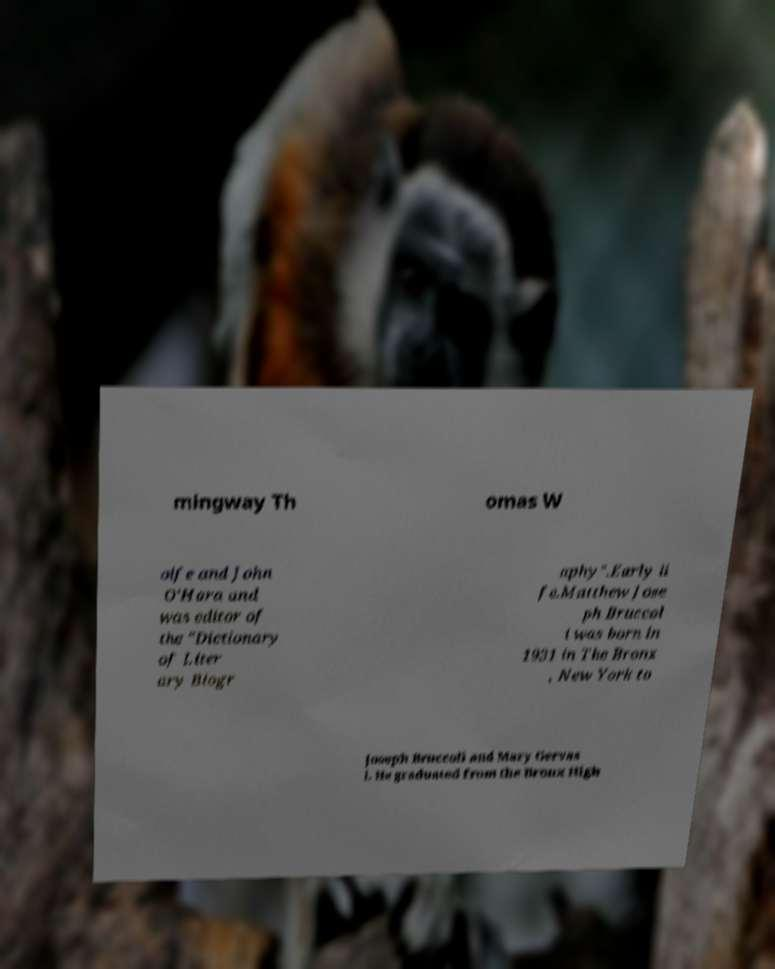For documentation purposes, I need the text within this image transcribed. Could you provide that? mingway Th omas W olfe and John O'Hara and was editor of the "Dictionary of Liter ary Biogr aphy".Early li fe.Matthew Jose ph Bruccol i was born in 1931 in The Bronx , New York to Joseph Bruccoli and Mary Gervas i. He graduated from the Bronx High 